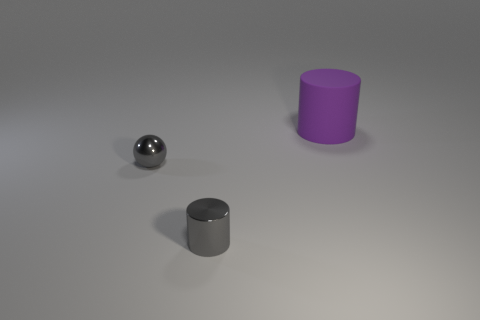Are there fewer tiny cylinders that are right of the large purple matte thing than tiny gray things?
Your answer should be very brief. Yes. How many small metal things are the same color as the rubber cylinder?
Your answer should be very brief. 0. How big is the thing in front of the tiny sphere?
Your answer should be very brief. Small. There is a gray thing that is on the left side of the tiny object that is in front of the tiny gray thing that is behind the tiny metal cylinder; what is its shape?
Give a very brief answer. Sphere. There is a object that is both to the left of the large matte cylinder and to the right of the tiny metal ball; what is its shape?
Keep it short and to the point. Cylinder. Is there a gray shiny cylinder of the same size as the matte thing?
Provide a short and direct response. No. Does the small metal thing that is in front of the ball have the same shape as the purple object?
Offer a very short reply. Yes. Is there a metallic object of the same shape as the purple rubber thing?
Provide a short and direct response. Yes. What shape is the metal object on the left side of the small gray thing that is in front of the tiny shiny sphere?
Offer a very short reply. Sphere. What color is the cylinder in front of the small sphere?
Offer a terse response. Gray. 